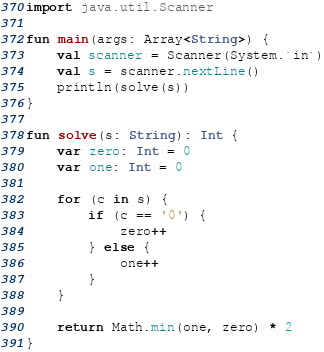Convert code to text. <code><loc_0><loc_0><loc_500><loc_500><_Kotlin_>import java.util.Scanner

fun main(args: Array<String>) {
    val scanner = Scanner(System.`in`)
    val s = scanner.nextLine()
    println(solve(s))
}

fun solve(s: String): Int {
    var zero: Int = 0
    var one: Int = 0

    for (c in s) {
        if (c == '0') {
            zero++
        } else {
            one++
        }
    }

    return Math.min(one, zero) * 2
}
</code> 